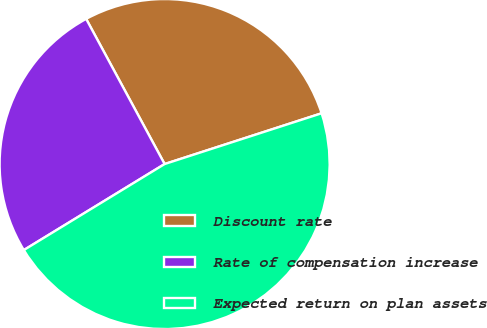Convert chart to OTSL. <chart><loc_0><loc_0><loc_500><loc_500><pie_chart><fcel>Discount rate<fcel>Rate of compensation increase<fcel>Expected return on plan assets<nl><fcel>27.91%<fcel>25.84%<fcel>46.25%<nl></chart> 